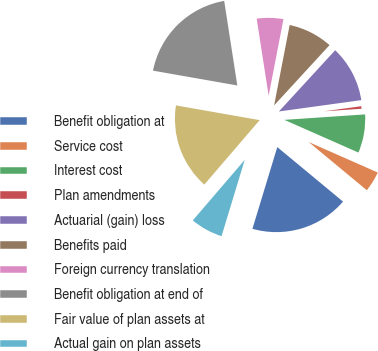Convert chart. <chart><loc_0><loc_0><loc_500><loc_500><pie_chart><fcel>Benefit obligation at<fcel>Service cost<fcel>Interest cost<fcel>Plan amendments<fcel>Actuarial (gain) loss<fcel>Benefits paid<fcel>Foreign currency translation<fcel>Benefit obligation at end of<fcel>Fair value of plan assets at<fcel>Actual gain on plan assets<nl><fcel>18.68%<fcel>4.4%<fcel>7.69%<fcel>1.1%<fcel>10.99%<fcel>8.79%<fcel>5.49%<fcel>19.78%<fcel>16.48%<fcel>6.59%<nl></chart> 